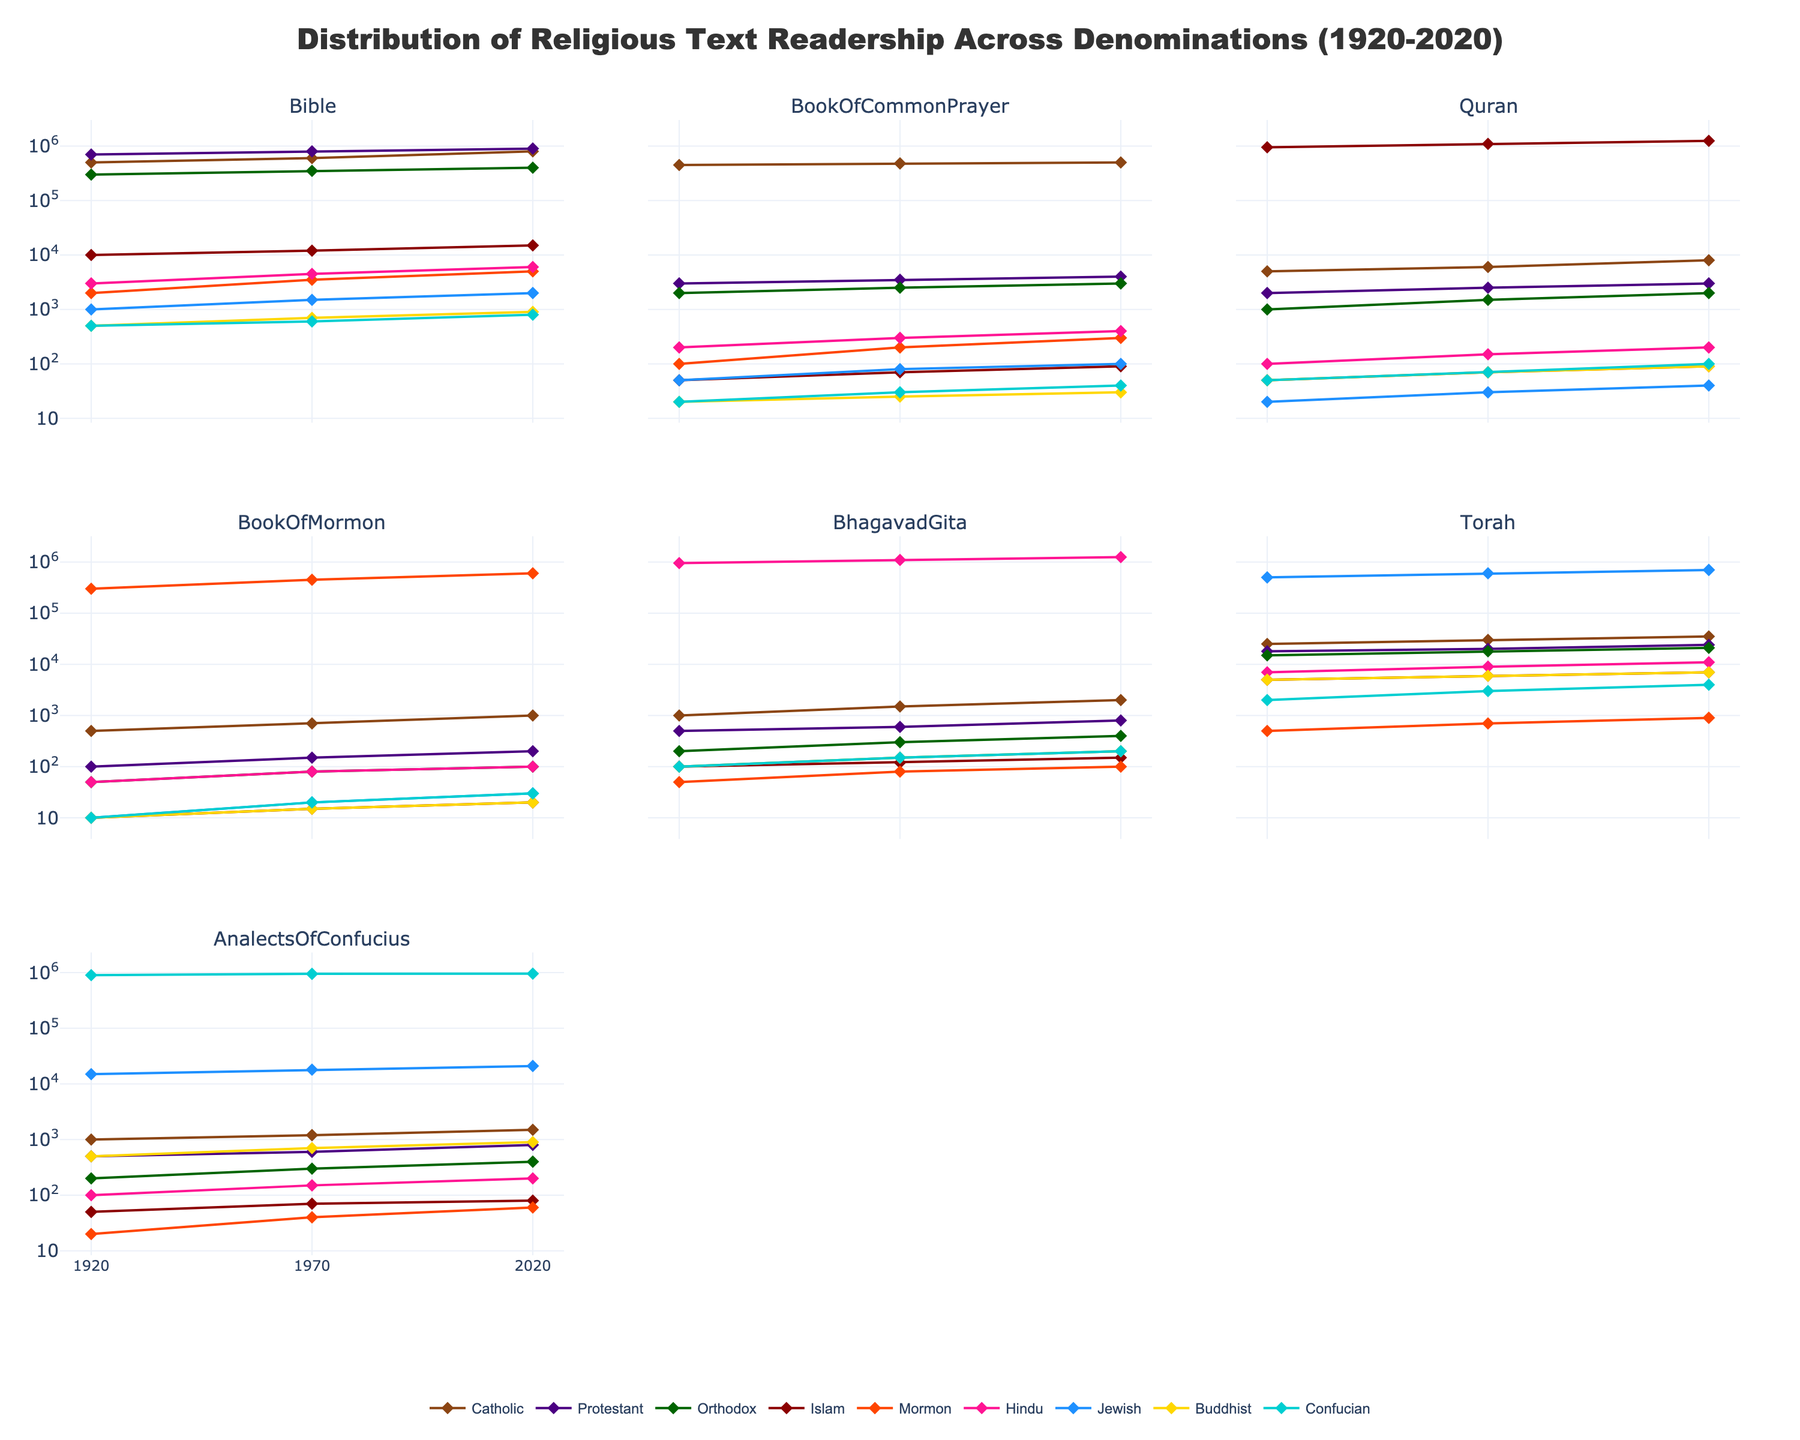Which denomination had the highest readership of the Bible in 2020? Look at the subplot for the Bible and compare the lines representing different denominations in the year 2020. The Protestant line reaches up to 900,000.
Answer: Protestant How did the readership of the Analects of Confucius change for the Confucian denomination from 1920 to 2020? Check the subplot for the Analects of Confucius and trace the line corresponding to the Confucian denomination from 1920 to 2020. It goes from 900,000 to 960,000.
Answer: Increased by 60,000 What is the range of readership numbers for the Torah across all denominations in 1970? Look at the subplot for the Torah and focus on the readership numbers for each denomination in the year 1970. The numbers range from the lowest (6,000 for Buddhist) to the highest (600,000 for Jewish).
Answer: 6,000 to 600,000 Which religious text saw the most significant overall increase in readership from 1920 to 2020 for the Mormon denomination? Identify the subplot lines for different texts corresponding to the Mormon denomination and calculate the increase for each from 1920 to 2020. The Book of Mormon increased from 300,000 to 600,000.
Answer: Book of Mormon How did the readership trends for the Quran differ between the Catholic and Islamic denominations from 1920 to 2020? Compare the subplot for the Quran focusing on the Catholic and Islamic lines over time. Catholic shows a slow increase from 5,000 to 8,000, while the Islamic line rose more steeply from 950,000 to 1,250,000.
Answer: Islamic saw a steeper increase What was the average readership of the Bhagavad Gita for the Hindu denomination from 1920 to 2020? Look at the subplot for the Bhagavad Gita and take the sums of readership numbers for Hindu in 1920, 1970, and 2020, then divide by 3. (950,000 + 1,100,000 + 1,250,000) / 3 = 1,100,000
Answer: 1,100,000 Which denominations had more readership of the Book of Common Prayer than the Quran in 2020? Compare the end points (2020) of each denomination on subplots for both the Book of Common Prayer and the Quran. Catholics, Protestants, and Orthodox had more readership of the Book of Common Prayer than the Quran.
Answer: Catholics, Protestants, Orthodox How did the readership of the Torah for the Jewish denomination vary between 1920 and 2020? Focus on the subplot for the Torah and trace the changes in the line representing Jewish denomination from 1920 to 2020. It grows from 500,000 to 700,000.
Answer: Increased by 200,000 Which text had the smallest readership among Buddhists in 2020? Look at the subplot and identify the smallest endpoint in 2020 for the Buddhist denomination. It is the Book of Common Prayer with a readership of around 30.
Answer: Book of Common Prayer 